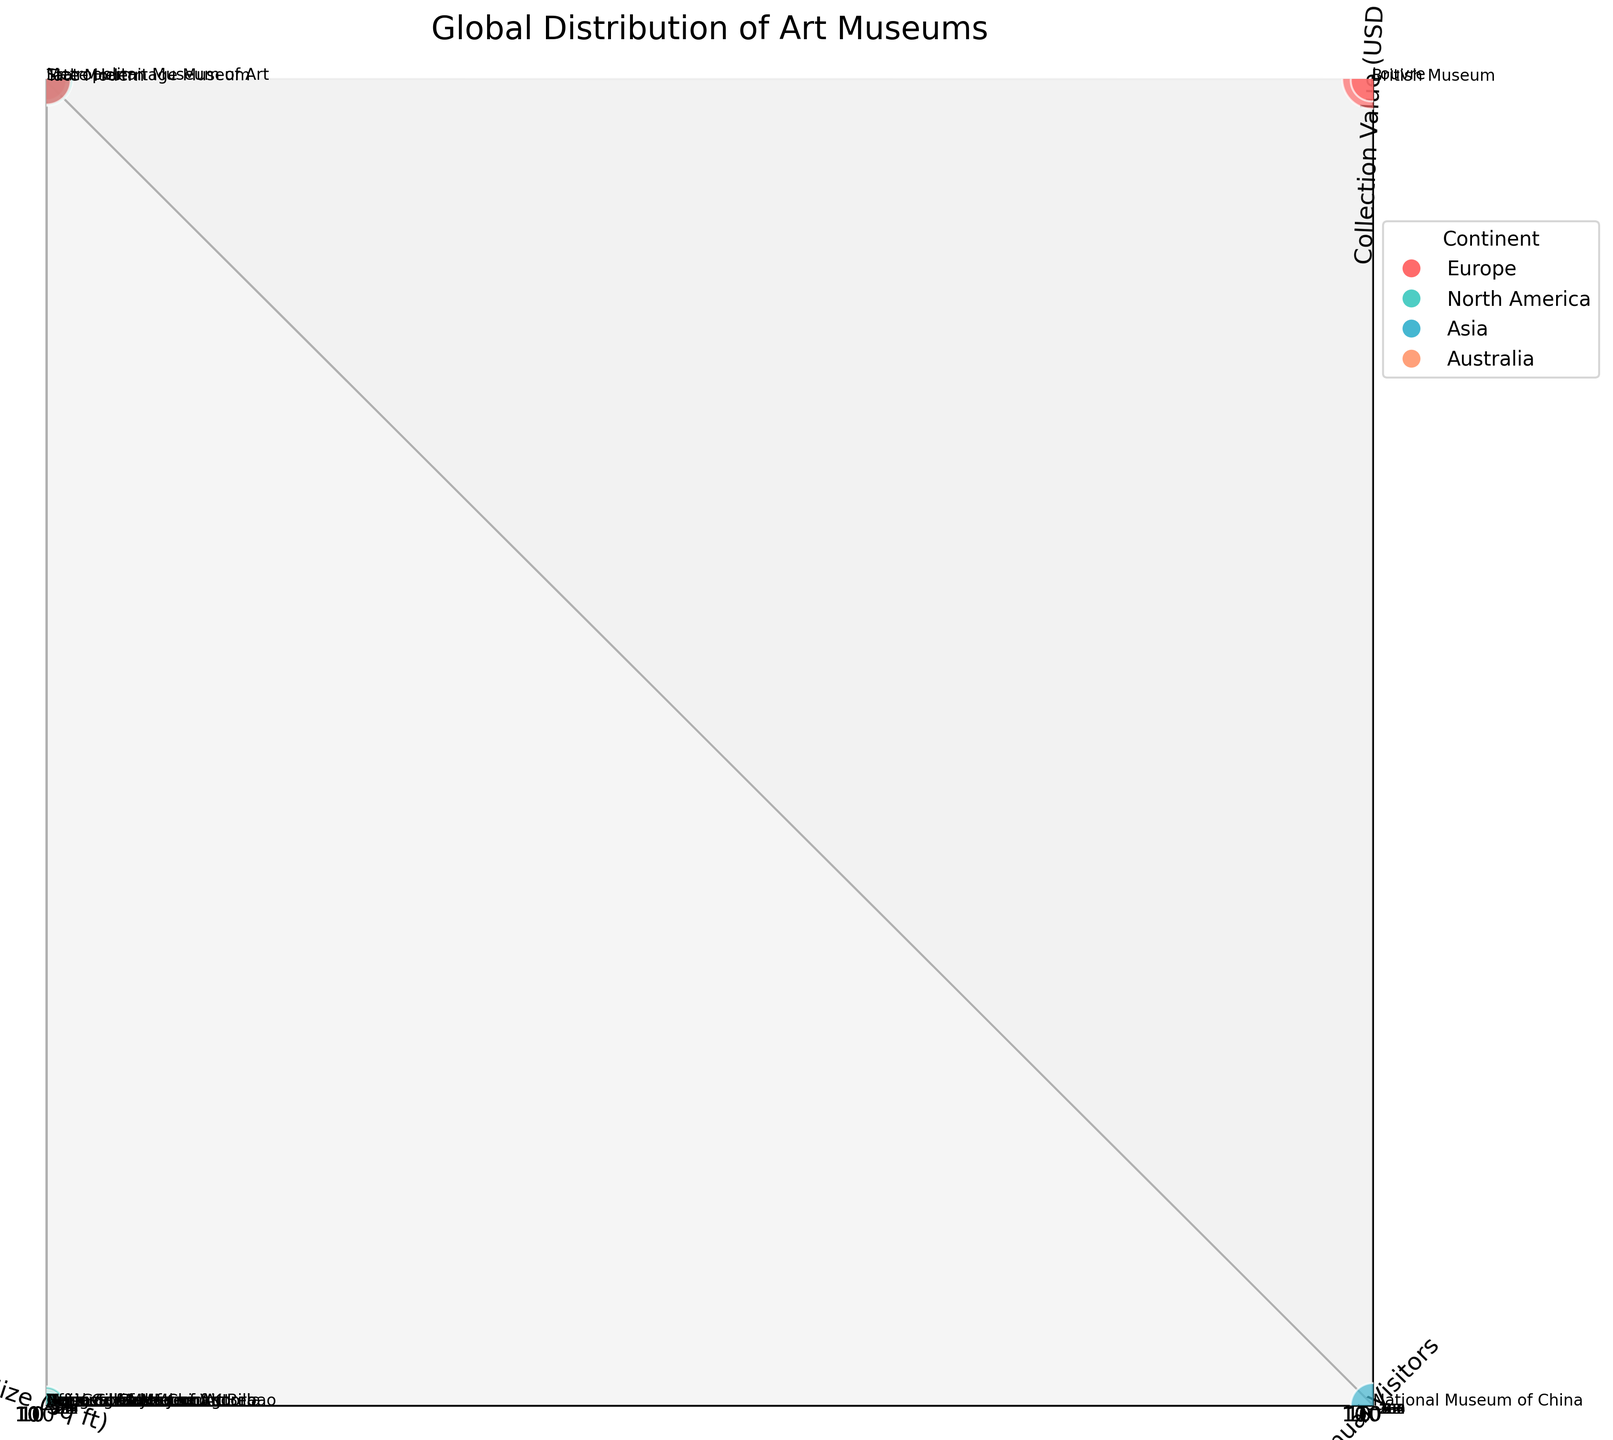What's the title of the figure? The title is displayed at the top of the figure. By observing, we see it states "Global Distribution of Art Museums".
Answer: Global Distribution of Art Museums Which museum has the largest floor size? By looking at the x-axis and the size dimension, we can see that "National Museum of China" has the largest size (1,950,000 sq ft).
Answer: National Museum of China Which museum receives the highest number of annual visitors? Observing the y-axis for the highest value, we note that "Louvre" has the highest number of annual visitors (9,600,000).
Answer: Louvre Which museum has the highest collection value? Referring to the z-axis and the size of the bubbles, "Louvre" also has the highest collection value (USD 45,000 million).
Answer: Louvre How many museums are in North America? The legend indicates the color representing North America, and we count the corresponding bubbles: "Metropolitan Museum of Art", "National Gallery of Art", "Museum of Modern Art", and "Art Institute of Chicago". There are 4 museums in North America.
Answer: 4 Which continent is represented by the most museums? By counting the colors corresponding to each continent in the legend, Europe has the most museums: "Louvre", "State Hermitage Museum", "Tate Modern", "British Museum", "Reina Sofia Museum", "Uffizi Gallery", "Guggenheim Museum Bilbao", and "Van Gogh Museum".
Answer: Europe What's the range of annual visitors for museums in Europe? Observing the y-axis for museums colored for Europe, the minimum number of visitors is 1,180,000 (Guggenheim Museum Bilbao) and the maximum number is 9,600,000 (Louvre).
Answer: 1,180,000 to 9,600,000 Which museum among the plotted ones has the smallest collection value? Looking at the z-axis for the smallest z-value and the smallest bubbles, "Guggenheim Museum Bilbao" has the smallest collection value (USD 2,500 million).
Answer: Guggenheim Museum Bilbao Compare the floor sizes of the "British Museum" and "Tate Modern". Which one is larger? Observing their positions on the x-axis, "British Museum" is at 990,000 sq ft, and "Tate Modern" is at 370,000 sq ft. The British Museum is larger.
Answer: British Museum What can be inferred from the sizes of the bubbles? The sizes of the bubbles represent the collection value of each museum. Larger bubbles indicate higher collection values. Thus, "Louvre" has the highest collection value, and "Guggenheim Museum Bilbao" has a relatively low collection value compared to others.
Answer: Collection value 